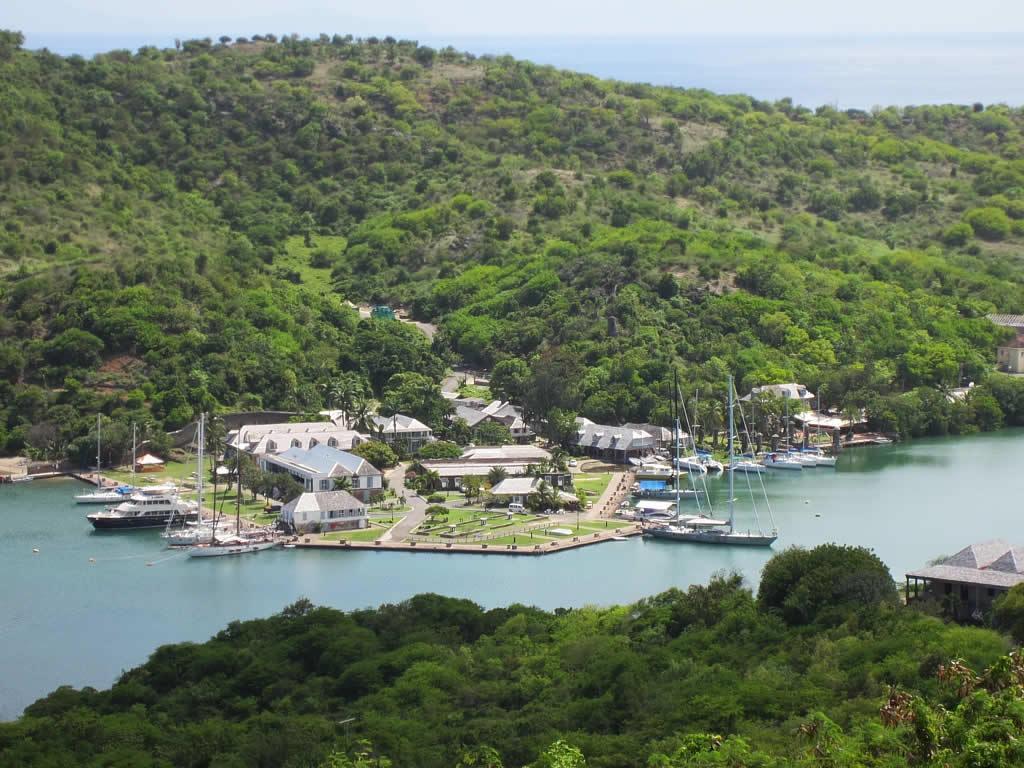Please provide a concise description of this image. This image consists of mountains covered with plants and trees. In the middle, there is water and there are, many houses along with boats. At the bottom, there are big trees. 